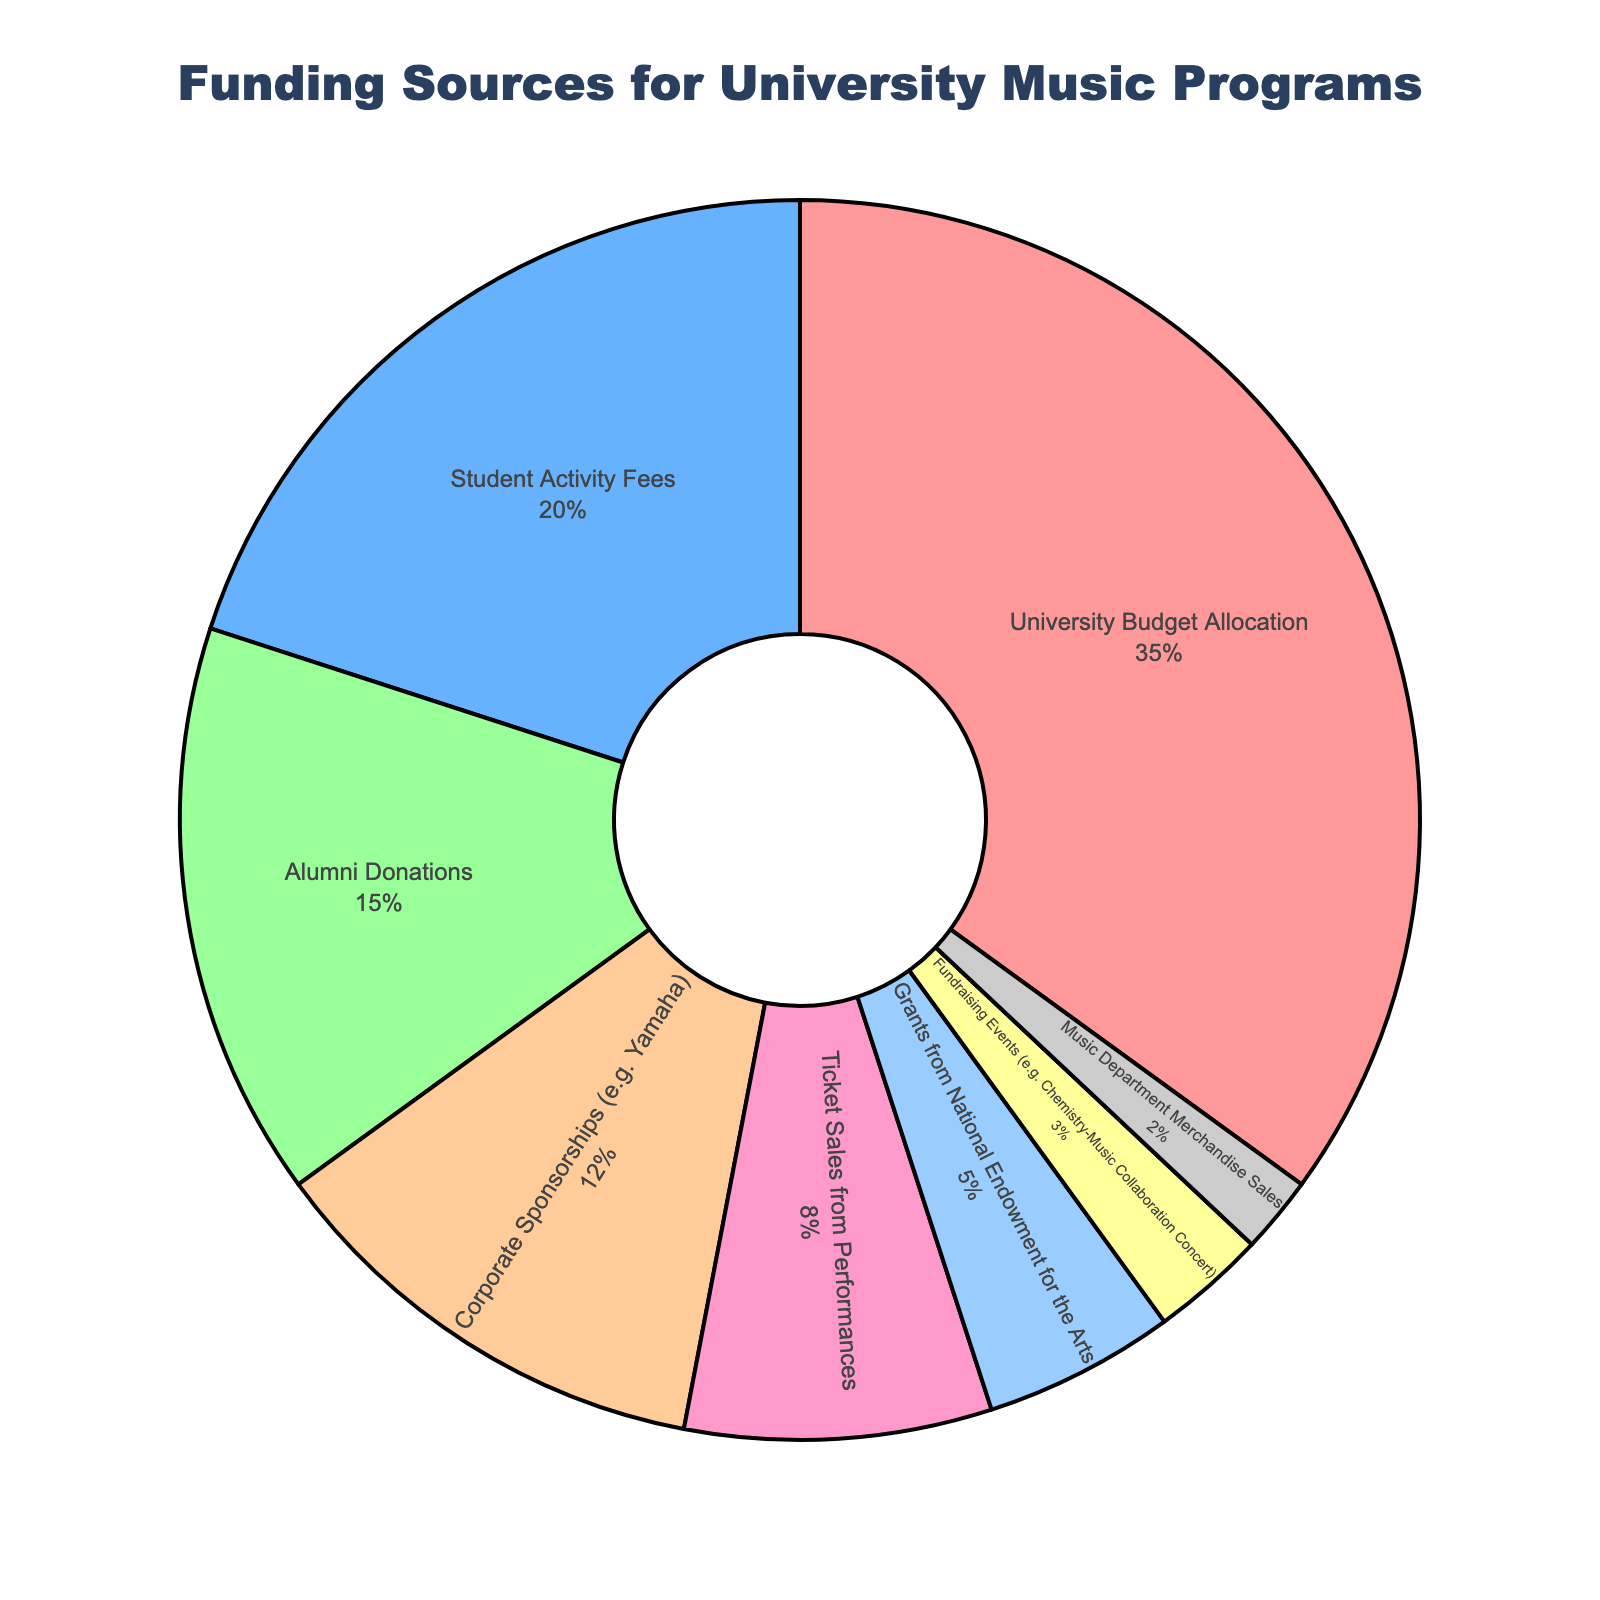Which funding source contributes the largest percentage? The pie chart shows that the "University Budget Allocation" takes up the largest portion with 35%.
Answer: University Budget Allocation What's the combined percentage of "Alumni Donations" and "Corporate Sponsorships"? The percentage for "Alumni Donations" is 15% and for "Corporate Sponsorships" is 12%. Summing them together gives 15% + 12% = 27%.
Answer: 27% Which is greater, the percentage from "Student Activity Fees" or "Ticket Sales from Performances"? The percentage from "Student Activity Fees" is 20%, and from "Ticket Sales from Performances" is 8%. 20% is greater than 8%.
Answer: Student Activity Fees How does the percentage for "Fundraising Events" compare to that for "Grants from National Endowment for the Arts"? The "Fundraising Events" contribute 3%, whereas the "Grants from National Endowment for the Arts" contribute 5%. Therefore, the "Grants from National Endowment for the Arts" contribute more.
Answer: Grants from National Endowment for the Arts If you combine the percentages of the three smallest categories, what is the sum? The smallest categories are "Music Department Merchandise Sales" (2%), "Fundraising Events" (3%), and "Grants from National Endowment for the Arts" (5%). Summing them gives 2% + 3% + 5% = 10%.
Answer: 10% Which two funding sources have a combined contribution equal to "University Budget Allocation"? The "University Budget Allocation" is 35%. The combined contribution of "Student Activity Fees" and "Alumni Donations" is 20% + 15% = 35%, which equals that of the "University Budget Allocation".
Answer: Student Activity Fees and Alumni Donations What is the difference in percentage between "Corporate Sponsorships" and "Ticket Sales from Performances"? "Corporate Sponsorships" contribute 12%, and "Ticket Sales from Performances" contribute 8%. The difference is 12% - 8% = 4%.
Answer: 4% Which funding source is represented by the lightest shade of blue? Referring to the pie chart, the lightest shade of blue corresponds to "Student Activity Fees."
Answer: Student Activity Fees Which funding source contributes the second-largest percentage? The second-largest percentage is contributed by "Student Activity Fees" with 20%.
Answer: Student Activity Fees How many funding sources contribute less than 10%? The funding sources that contribute less than 10% are "Ticket Sales from Performances" (8%), "Grants from National Endowment for the Arts" (5%), "Fundraising Events" (3%), and "Music Department Merchandise Sales" (2%). There are four such sources.
Answer: 4 